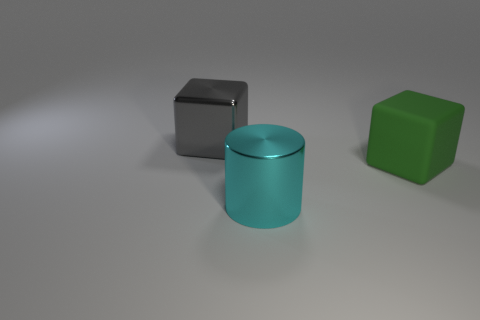Add 2 large green cubes. How many objects exist? 5 Subtract all gray blocks. How many blocks are left? 1 Subtract all blocks. How many objects are left? 1 Subtract 2 cubes. How many cubes are left? 0 Subtract all gray cylinders. Subtract all red blocks. How many cylinders are left? 1 Subtract all cyan metallic objects. Subtract all yellow things. How many objects are left? 2 Add 3 cyan things. How many cyan things are left? 4 Add 1 gray matte objects. How many gray matte objects exist? 1 Subtract 0 purple cylinders. How many objects are left? 3 Subtract all cyan spheres. How many gray cylinders are left? 0 